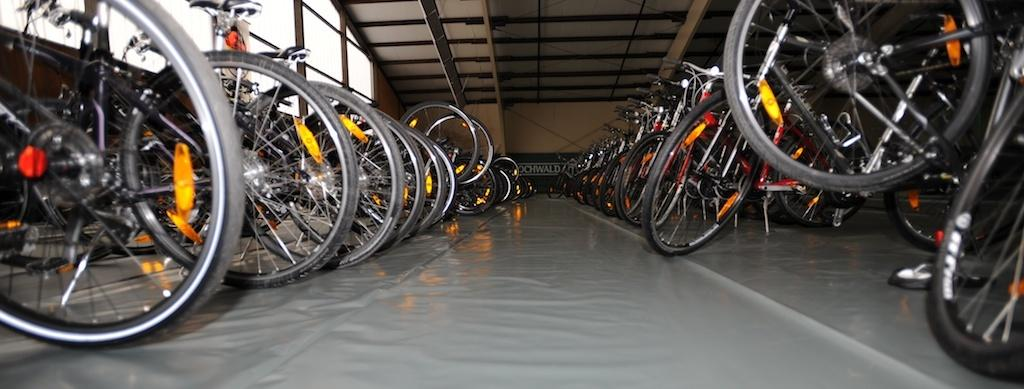What type of vehicles can be seen in the image? There are bicycles in the image. What is the background of the image made of? There is a wall in the image. What can be used to display information or messages in the image? There is a text board in the image. What allows natural light to enter the space in the image? There are windows in the image. What provides protection from the elements in the image? There is a roof for shelter in the image. What surface is visible under the bicycles in the image? There is a floor visible in the image. Where can the goldfish be found swimming in the image? There are no goldfish present in the image. What is the name of the downtown area depicted in the image? The image does not depict a downtown area, so it cannot be named. 